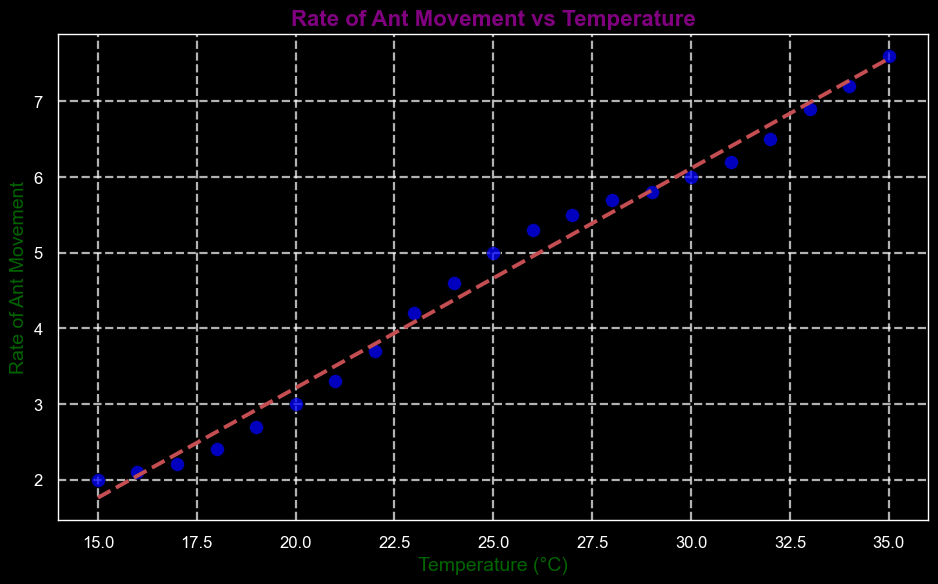What is the trend in the scatter plot? The scatter plot shows a positive trend, meaning as the temperature increases, the rate of ant movement also increases. This is indicated by the upward slope of the trend line.
Answer: Positive trend At what temperature is the Rate of Ant Movement equal to 5? By looking at the scatter plot, you can see that the data point where the Rate of Ant Movement is 5 corresponds to a temperature of 25°C.
Answer: 25°C How many data points are there in the scatter plot? By counting each of the individual data points shown in the plot, you find there are 21 data points in total.
Answer: 21 Which data point shows the highest rate of ant movement, and what is its temperature? The highest Rate of Ant Movement visible in the plot is 7.6, which occurs at a temperature of 35°C.
Answer: 35°C What is the average rate of ant movement for temperatures 20°C and above? First, identify the rates for temperatures 20°C and above: (3, 3.3, 3.7, 4.2, 4.6, 5, 5.3, 5.5, 5.7, 5.8, 6, 6.2, 6.5, 6.9, 7.2, 7.6). Then, sum these rates and divide by the number of data points: (3+3.3+3.7+4.2+4.6+5+5.3+5.5+5.7+5.8+6+6.2+6.5+6.9+7.2+7.6)/16 = 5.18.
Answer: 5.18 How much does the rate of ant movement increase from a temperature of 19°C to 24°C? The rate of ant movement at 19°C is 2.7, and at 24°C it is 4.6. The increase is 4.6 - 2.7 = 1.9.
Answer: 1.9 Which data point is closest to the trend line but not on it? The data point closest to the trend line without being on it has to be compared visually. This would require carefully comparing distances of points to the line, but given visual inspection, it appears around Temperature 21°C or 26°C.
Answer: Temperature of 21°C or 26°C Is there any temperature where the rate of ant movement does not increase compared to the previous temperature? By checking the scatter plot for such instances, no temperature shows a decrease in the rate of ant movement compared to the preceding temperature; all increases are slight but present.
Answer: No What is the rate of ant movement at 30°C compared to 15°C? At 30°C, the rate is 6, and at 15°C, it's 2. The difference is 6 - 2 = 4. Therefore, the rate at 30°C is 4 units greater than at 15°C.
Answer: 4 units greater 